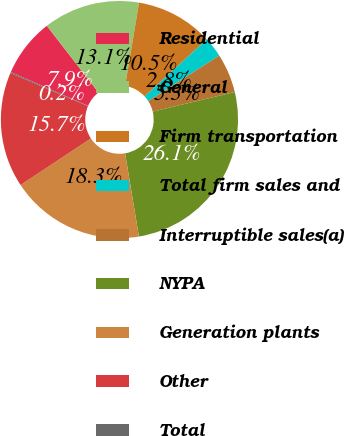Convert chart to OTSL. <chart><loc_0><loc_0><loc_500><loc_500><pie_chart><fcel>Residential<fcel>General<fcel>Firm transportation<fcel>Total firm sales and<fcel>Interruptible sales(a)<fcel>NYPA<fcel>Generation plants<fcel>Other<fcel>Total<nl><fcel>7.94%<fcel>13.13%<fcel>10.53%<fcel>2.75%<fcel>5.34%<fcel>26.11%<fcel>18.32%<fcel>15.73%<fcel>0.15%<nl></chart> 